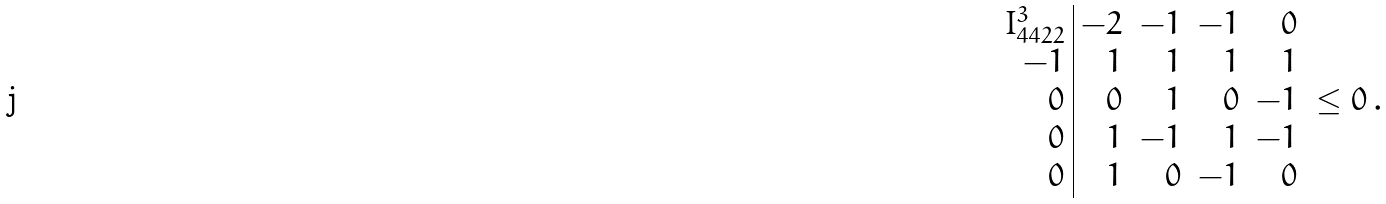<formula> <loc_0><loc_0><loc_500><loc_500>\begin{array} { r | r r r r } I _ { 4 4 2 2 } ^ { 3 } & - 2 & - 1 & - 1 & 0 \\ - 1 & 1 & 1 & 1 & 1 \\ 0 & 0 & 1 & 0 & - 1 \\ 0 & 1 & - 1 & 1 & - 1 \\ 0 & 1 & 0 & - 1 & 0 \\ \end{array} \leq 0 \, .</formula> 